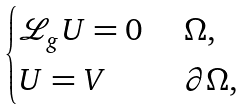Convert formula to latex. <formula><loc_0><loc_0><loc_500><loc_500>\begin{cases} \mathcal { L } _ { g } U = 0 & \ \Omega , \\ U = V & \ \partial \Omega , \end{cases}</formula> 